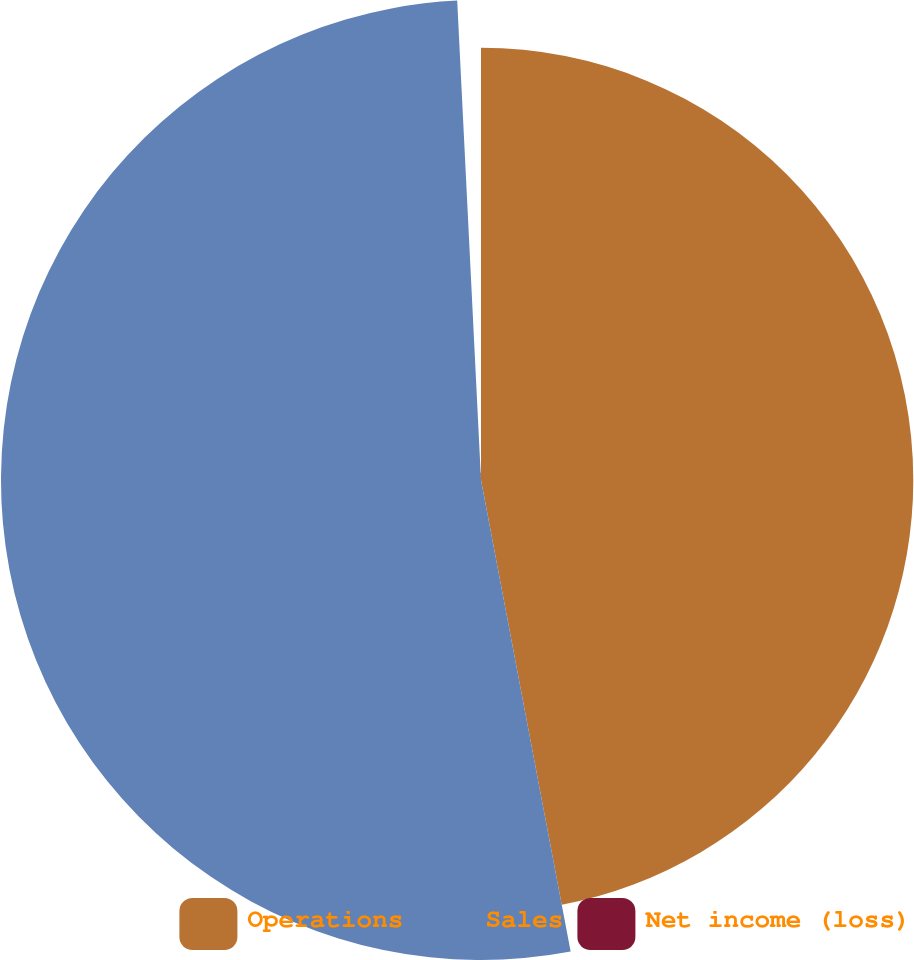<chart> <loc_0><loc_0><loc_500><loc_500><pie_chart><fcel>Operations<fcel>Sales<fcel>Net income (loss)<nl><fcel>47.01%<fcel>52.2%<fcel>0.79%<nl></chart> 